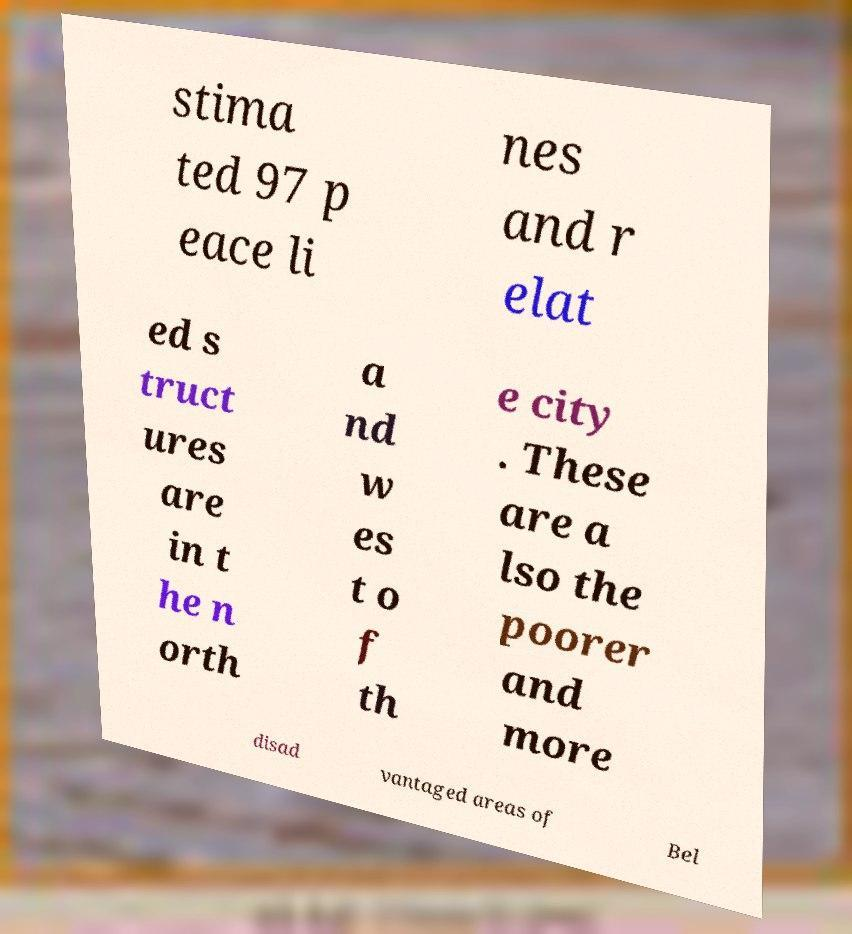Could you assist in decoding the text presented in this image and type it out clearly? stima ted 97 p eace li nes and r elat ed s truct ures are in t he n orth a nd w es t o f th e city . These are a lso the poorer and more disad vantaged areas of Bel 